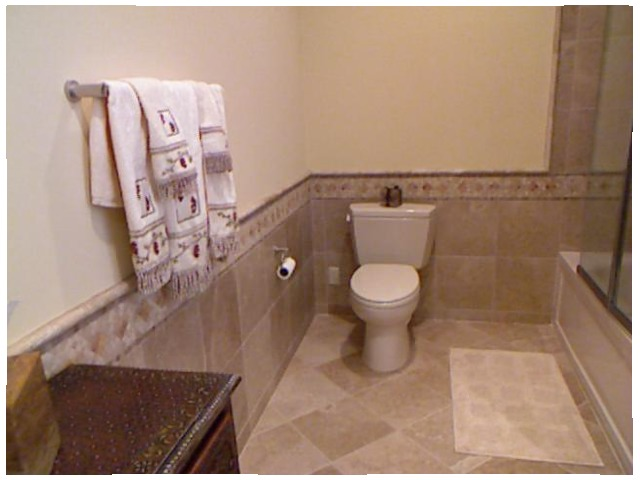<image>
Is there a towel in front of the wall? Yes. The towel is positioned in front of the wall, appearing closer to the camera viewpoint. Where is the table in relation to the box? Is it under the box? Yes. The table is positioned underneath the box, with the box above it in the vertical space. Is there a towel above the table? No. The towel is not positioned above the table. The vertical arrangement shows a different relationship. 